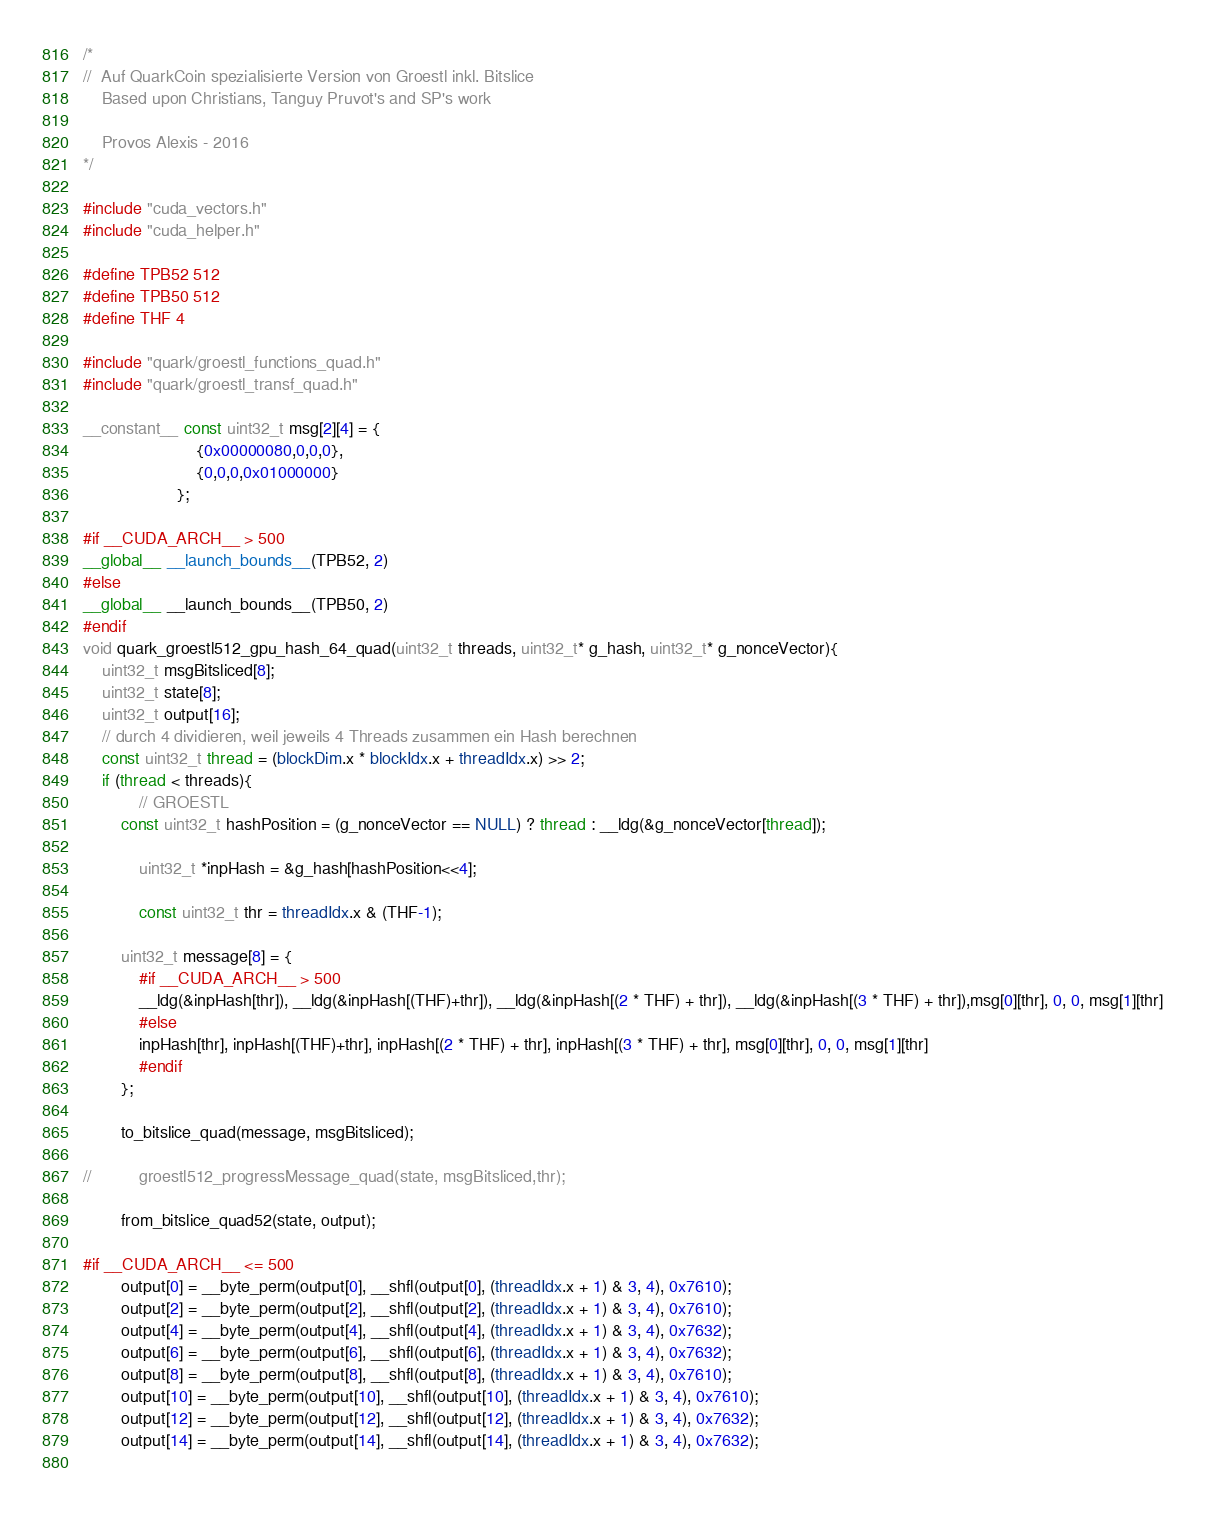Convert code to text. <code><loc_0><loc_0><loc_500><loc_500><_Cuda_>/*
//	Auf QuarkCoin spezialisierte Version von Groestl inkl. Bitslice
	Based upon Christians, Tanguy Pruvot's and SP's work
		
	Provos Alexis - 2016
*/

#include "cuda_vectors.h"
#include "cuda_helper.h"

#define TPB52 512
#define TPB50 512
#define THF 4

#include "quark/groestl_functions_quad.h"
#include "quark/groestl_transf_quad.h"

__constant__ const uint32_t msg[2][4] = {
						{0x00000080,0,0,0},
						{0,0,0,0x01000000}
					};

#if __CUDA_ARCH__ > 500
__global__ __launch_bounds__(TPB52, 2)
#else
__global__ __launch_bounds__(TPB50, 2)
#endif
void quark_groestl512_gpu_hash_64_quad(uint32_t threads, uint32_t* g_hash, uint32_t* g_nonceVector){
	uint32_t msgBitsliced[8];
	uint32_t state[8];
	uint32_t output[16];
	// durch 4 dividieren, weil jeweils 4 Threads zusammen ein Hash berechnen
	const uint32_t thread = (blockDim.x * blockIdx.x + threadIdx.x) >> 2;
	if (thread < threads){
	        // GROESTL
		const uint32_t hashPosition = (g_nonceVector == NULL) ? thread : __ldg(&g_nonceVector[thread]);

	        uint32_t *inpHash = &g_hash[hashPosition<<4];

	        const uint32_t thr = threadIdx.x & (THF-1);

		uint32_t message[8] = {
			#if __CUDA_ARCH__ > 500
			__ldg(&inpHash[thr]), __ldg(&inpHash[(THF)+thr]), __ldg(&inpHash[(2 * THF) + thr]), __ldg(&inpHash[(3 * THF) + thr]),msg[0][thr], 0, 0, msg[1][thr]
			#else
			inpHash[thr], inpHash[(THF)+thr], inpHash[(2 * THF) + thr], inpHash[(3 * THF) + thr], msg[0][thr], 0, 0, msg[1][thr]
			#endif
		};

		to_bitslice_quad(message, msgBitsliced);

//	        groestl512_progressMessage_quad(state, msgBitsliced,thr);

		from_bitslice_quad52(state, output);

#if __CUDA_ARCH__ <= 500
		output[0] = __byte_perm(output[0], __shfl(output[0], (threadIdx.x + 1) & 3, 4), 0x7610);
		output[2] = __byte_perm(output[2], __shfl(output[2], (threadIdx.x + 1) & 3, 4), 0x7610);
		output[4] = __byte_perm(output[4], __shfl(output[4], (threadIdx.x + 1) & 3, 4), 0x7632);
		output[6] = __byte_perm(output[6], __shfl(output[6], (threadIdx.x + 1) & 3, 4), 0x7632);
		output[8] = __byte_perm(output[8], __shfl(output[8], (threadIdx.x + 1) & 3, 4), 0x7610);
		output[10] = __byte_perm(output[10], __shfl(output[10], (threadIdx.x + 1) & 3, 4), 0x7610);
		output[12] = __byte_perm(output[12], __shfl(output[12], (threadIdx.x + 1) & 3, 4), 0x7632);
		output[14] = __byte_perm(output[14], __shfl(output[14], (threadIdx.x + 1) & 3, 4), 0x7632);
	</code> 